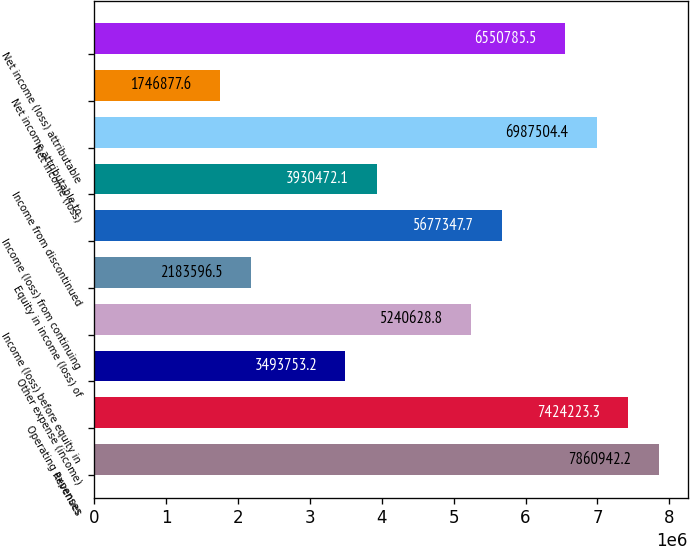Convert chart. <chart><loc_0><loc_0><loc_500><loc_500><bar_chart><fcel>Revenues<fcel>Operating expenses<fcel>Other expense (income)<fcel>Income (loss) before equity in<fcel>Equity in income (loss) of<fcel>Income (loss) from continuing<fcel>Income from discontinued<fcel>Net income (loss)<fcel>Net income attributable to<fcel>Net income (loss) attributable<nl><fcel>7.86094e+06<fcel>7.42422e+06<fcel>3.49375e+06<fcel>5.24063e+06<fcel>2.1836e+06<fcel>5.67735e+06<fcel>3.93047e+06<fcel>6.9875e+06<fcel>1.74688e+06<fcel>6.55079e+06<nl></chart> 